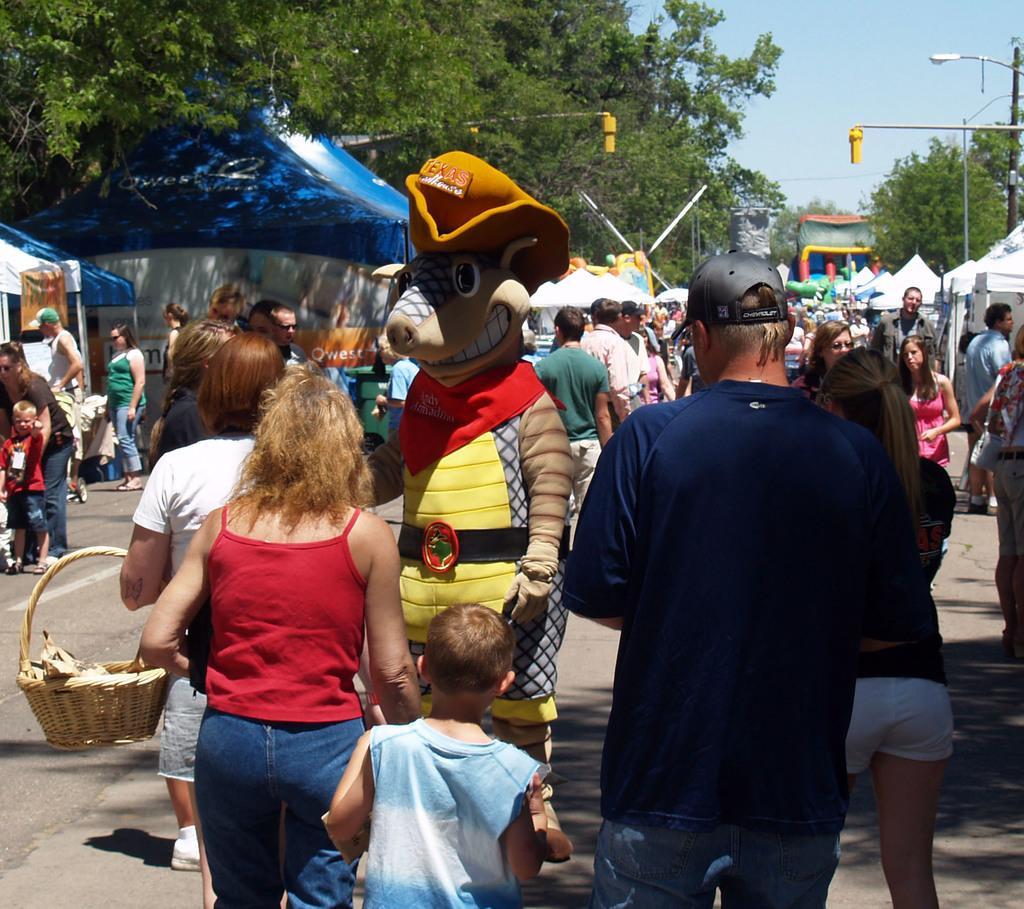How would you summarize this image in a sentence or two? In this picture there is a woman who is wearing t-shirt and jeans, beside her there is a boy who is wearing t-shirt. In front of them there is a person who is wearing the costume. In front of that we can see a woman wearing white t-shirt and short. On the right there is a woman who is wearing blue shirt and t-shirt. In the background we can see group of person were standing on the road. On the right background we can see tents, street light, pole and other objects. On the left we can see the group of persons were standing near to the tent. 